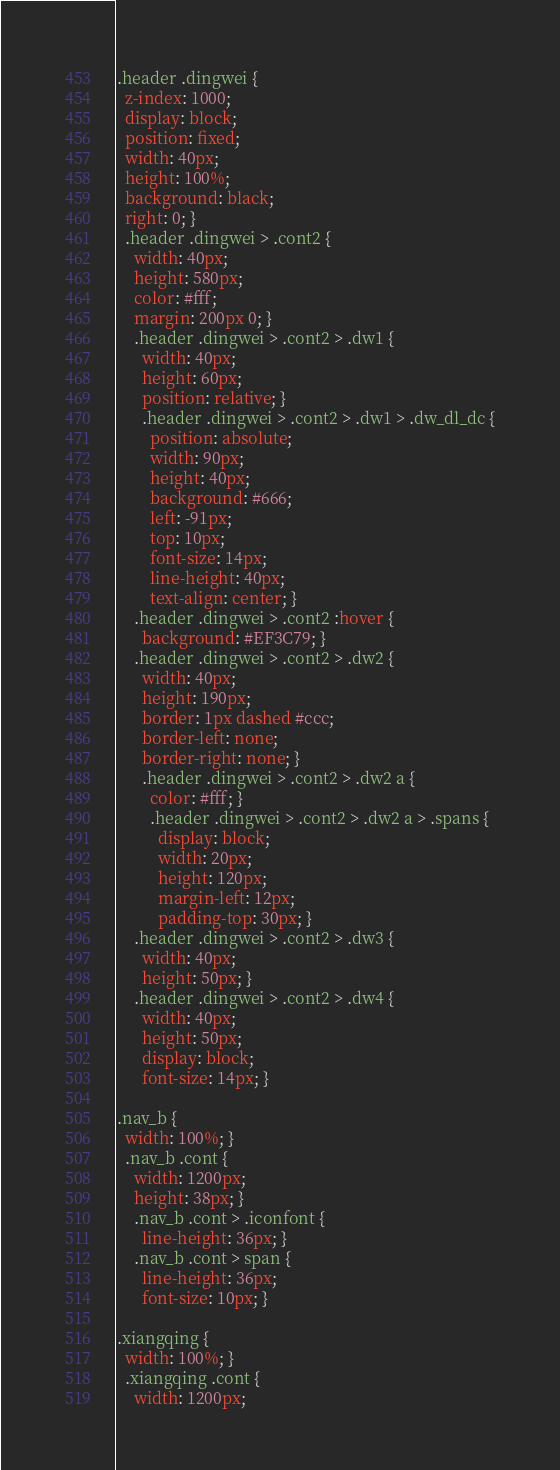<code> <loc_0><loc_0><loc_500><loc_500><_CSS_>.header .dingwei {
  z-index: 1000;
  display: block;
  position: fixed;
  width: 40px;
  height: 100%;
  background: black;
  right: 0; }
  .header .dingwei > .cont2 {
    width: 40px;
    height: 580px;
    color: #fff;
    margin: 200px 0; }
    .header .dingwei > .cont2 > .dw1 {
      width: 40px;
      height: 60px;
      position: relative; }
      .header .dingwei > .cont2 > .dw1 > .dw_dl_dc {
        position: absolute;
        width: 90px;
        height: 40px;
        background: #666;
        left: -91px;
        top: 10px;
        font-size: 14px;
        line-height: 40px;
        text-align: center; }
    .header .dingwei > .cont2 :hover {
      background: #EF3C79; }
    .header .dingwei > .cont2 > .dw2 {
      width: 40px;
      height: 190px;
      border: 1px dashed #ccc;
      border-left: none;
      border-right: none; }
      .header .dingwei > .cont2 > .dw2 a {
        color: #fff; }
        .header .dingwei > .cont2 > .dw2 a > .spans {
          display: block;
          width: 20px;
          height: 120px;
          margin-left: 12px;
          padding-top: 30px; }
    .header .dingwei > .cont2 > .dw3 {
      width: 40px;
      height: 50px; }
    .header .dingwei > .cont2 > .dw4 {
      width: 40px;
      height: 50px;
      display: block;
      font-size: 14px; }

.nav_b {
  width: 100%; }
  .nav_b .cont {
    width: 1200px;
    height: 38px; }
    .nav_b .cont > .iconfont {
      line-height: 36px; }
    .nav_b .cont > span {
      line-height: 36px;
      font-size: 10px; }

.xiangqing {
  width: 100%; }
  .xiangqing .cont {
    width: 1200px;</code> 